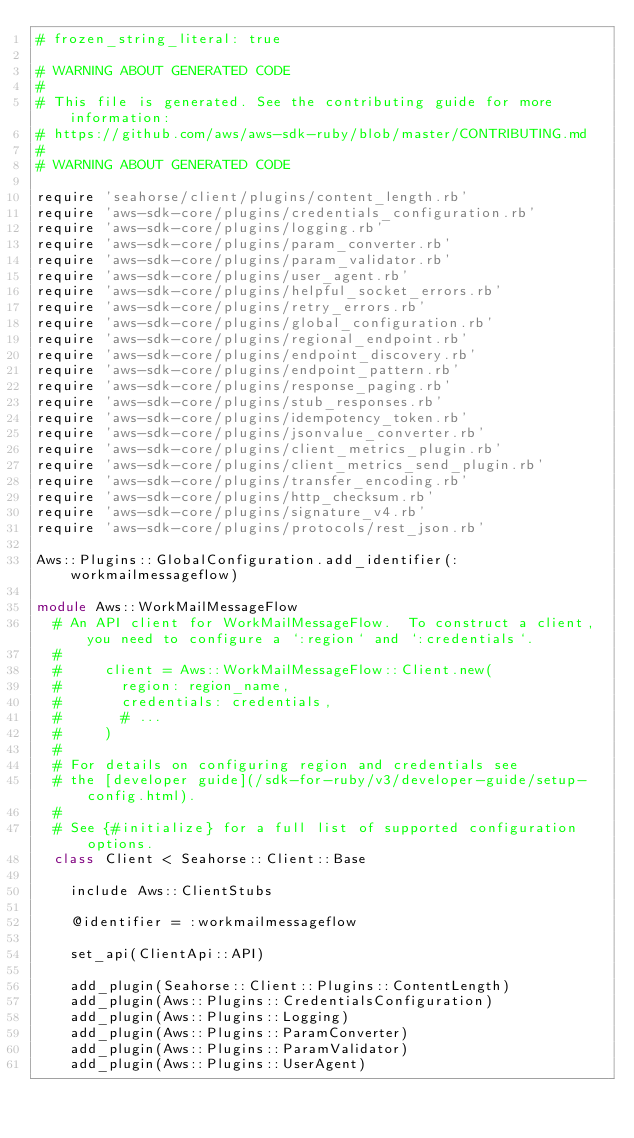Convert code to text. <code><loc_0><loc_0><loc_500><loc_500><_Ruby_># frozen_string_literal: true

# WARNING ABOUT GENERATED CODE
#
# This file is generated. See the contributing guide for more information:
# https://github.com/aws/aws-sdk-ruby/blob/master/CONTRIBUTING.md
#
# WARNING ABOUT GENERATED CODE

require 'seahorse/client/plugins/content_length.rb'
require 'aws-sdk-core/plugins/credentials_configuration.rb'
require 'aws-sdk-core/plugins/logging.rb'
require 'aws-sdk-core/plugins/param_converter.rb'
require 'aws-sdk-core/plugins/param_validator.rb'
require 'aws-sdk-core/plugins/user_agent.rb'
require 'aws-sdk-core/plugins/helpful_socket_errors.rb'
require 'aws-sdk-core/plugins/retry_errors.rb'
require 'aws-sdk-core/plugins/global_configuration.rb'
require 'aws-sdk-core/plugins/regional_endpoint.rb'
require 'aws-sdk-core/plugins/endpoint_discovery.rb'
require 'aws-sdk-core/plugins/endpoint_pattern.rb'
require 'aws-sdk-core/plugins/response_paging.rb'
require 'aws-sdk-core/plugins/stub_responses.rb'
require 'aws-sdk-core/plugins/idempotency_token.rb'
require 'aws-sdk-core/plugins/jsonvalue_converter.rb'
require 'aws-sdk-core/plugins/client_metrics_plugin.rb'
require 'aws-sdk-core/plugins/client_metrics_send_plugin.rb'
require 'aws-sdk-core/plugins/transfer_encoding.rb'
require 'aws-sdk-core/plugins/http_checksum.rb'
require 'aws-sdk-core/plugins/signature_v4.rb'
require 'aws-sdk-core/plugins/protocols/rest_json.rb'

Aws::Plugins::GlobalConfiguration.add_identifier(:workmailmessageflow)

module Aws::WorkMailMessageFlow
  # An API client for WorkMailMessageFlow.  To construct a client, you need to configure a `:region` and `:credentials`.
  #
  #     client = Aws::WorkMailMessageFlow::Client.new(
  #       region: region_name,
  #       credentials: credentials,
  #       # ...
  #     )
  #
  # For details on configuring region and credentials see
  # the [developer guide](/sdk-for-ruby/v3/developer-guide/setup-config.html).
  #
  # See {#initialize} for a full list of supported configuration options.
  class Client < Seahorse::Client::Base

    include Aws::ClientStubs

    @identifier = :workmailmessageflow

    set_api(ClientApi::API)

    add_plugin(Seahorse::Client::Plugins::ContentLength)
    add_plugin(Aws::Plugins::CredentialsConfiguration)
    add_plugin(Aws::Plugins::Logging)
    add_plugin(Aws::Plugins::ParamConverter)
    add_plugin(Aws::Plugins::ParamValidator)
    add_plugin(Aws::Plugins::UserAgent)</code> 